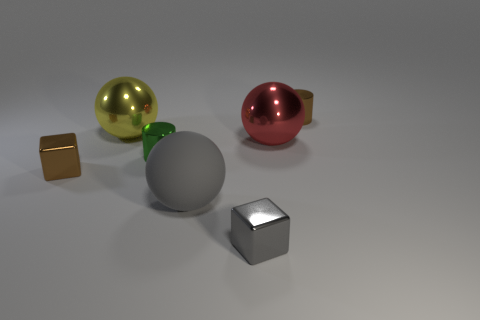Subtract all yellow cylinders. Subtract all cyan balls. How many cylinders are left? 2 Add 1 blue things. How many objects exist? 8 Subtract all cubes. How many objects are left? 5 Subtract 0 cyan blocks. How many objects are left? 7 Subtract all big cyan matte things. Subtract all matte things. How many objects are left? 6 Add 3 brown metallic cylinders. How many brown metallic cylinders are left? 4 Add 7 gray blocks. How many gray blocks exist? 8 